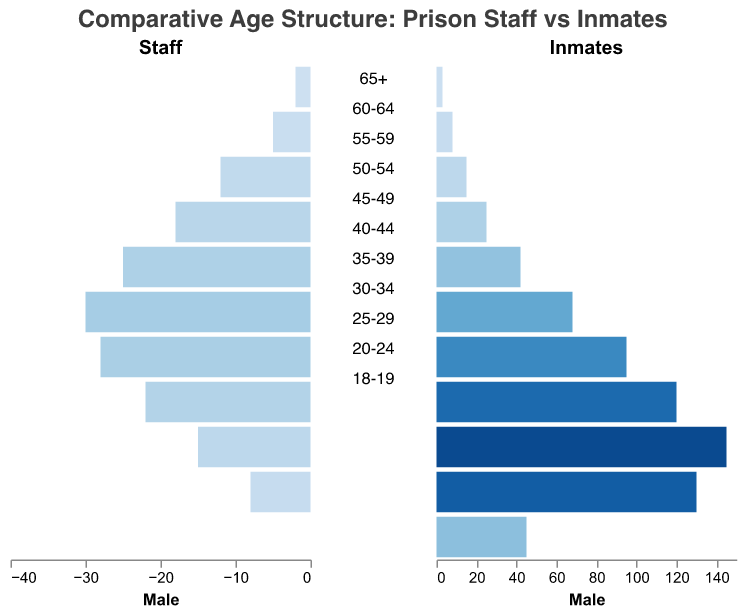How many age groups are depicted in the population pyramid? The figure shows various age categories, named explicitly on the y-axis, ranging from "18-19" to "65+"; by counting them, we find there are 11 distinct age groups.
Answer: 11 What is the approximate number of male inmates in the "30-34" age group? The number of male inmates in the "30-34" age group can be read directly from the figure. According to the height and scale of the bar for this age group, it is about 120.
Answer: 120 Are there more female prison staff or female inmates in the "45-49" age group? We compare the bars for female staff and female inmates in the "45-49" age group. The bar for female staff shows 20, while the bar for female inmates shows 12, indicating that there are more female staff in this age group.
Answer: Female prison staff By how many do male staff in the "50-54" age group exceed female staff in the same group? We subtract the number of female staff from the number of male staff in the "50-54" age group. Male staff are 18 and female staff are 14. Therefore, the difference is 18 - 14 = 4.
Answer: 4 Which age group has the highest number of inmates? By examining the height of the orange bars for all age groups, we see the highest bar corresponds to the "25-29" age group, indicating the highest number of inmates.
Answer: 25-29 Compare the male inmates and staff numbers in the "40-44" age group. Who are more and by how much? The number of male inmates in the "40-44" age group is 68, whereas for male staff, it is 30. Subtracting these gives 68 - 30 = 38, indicating that there are 38 more male inmates than male staff in this group.
Answer: Male inmates by 38 What is the total number of staff members in the "60-64" age group? Adding the number of male and female staff in this group, which are 5 and 3 respectively, gives us 5 + 3 = 8.
Answer: 8 Do any age groups have no male or female staff? By checking the bars for male and female staff across all age groups, we can see that the "18-19" age group has zero bars for both male and female staff.
Answer: Yes What is the ratio of male to female inmates in the "20-24" age group? The number of male inmates in the "20-24" age group is 130, while the number of female inmates is 35. The ratio can be calculated as 130:35, which simplifies to approximately 3.7:1.
Answer: 3.7:1 